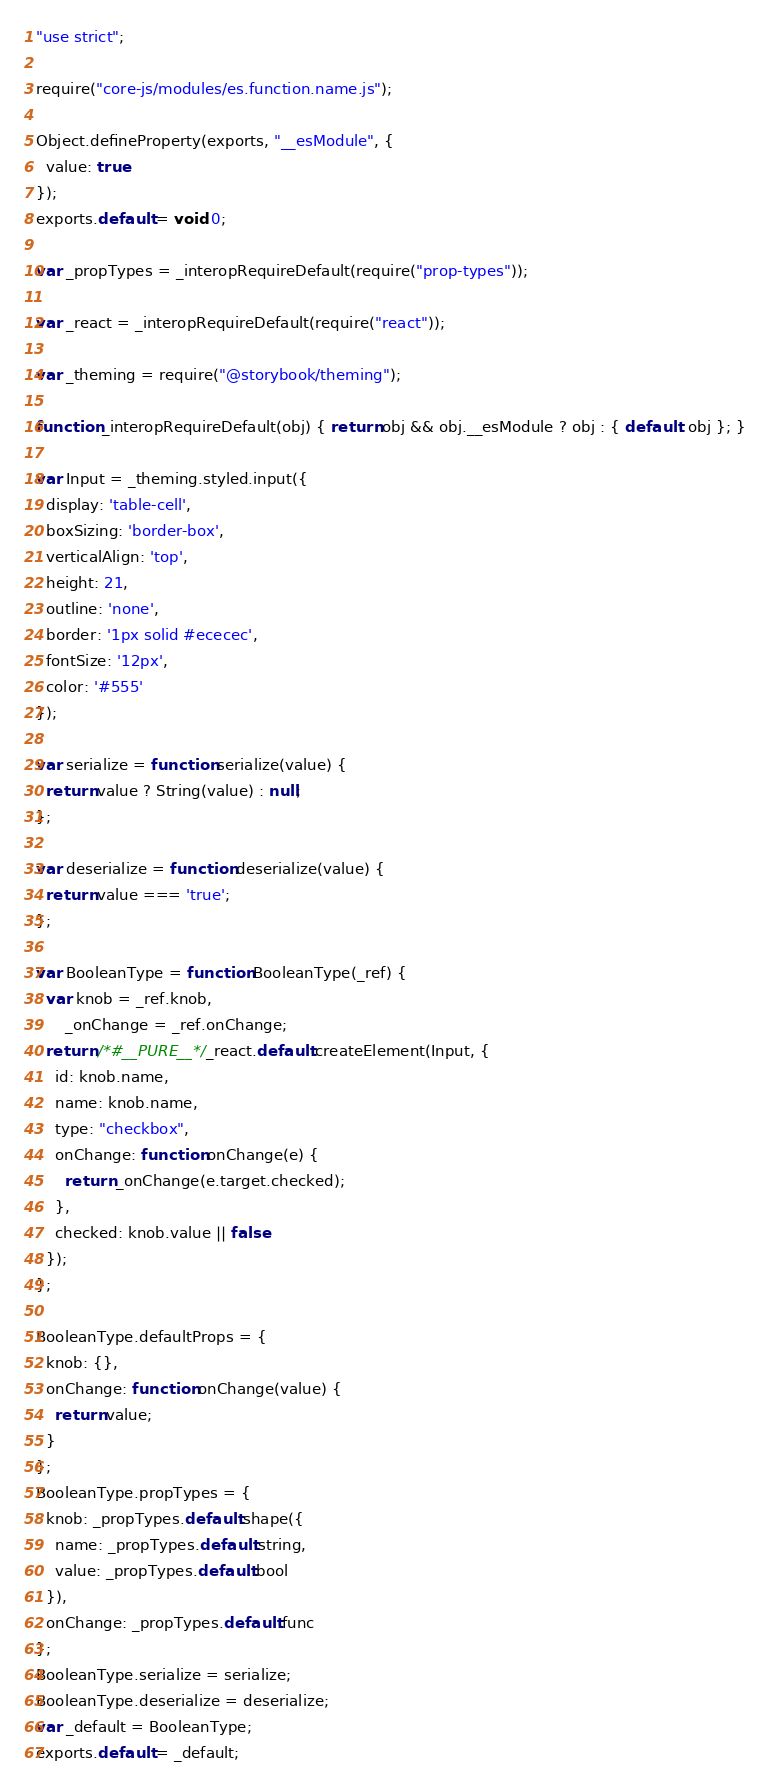Convert code to text. <code><loc_0><loc_0><loc_500><loc_500><_JavaScript_>"use strict";

require("core-js/modules/es.function.name.js");

Object.defineProperty(exports, "__esModule", {
  value: true
});
exports.default = void 0;

var _propTypes = _interopRequireDefault(require("prop-types"));

var _react = _interopRequireDefault(require("react"));

var _theming = require("@storybook/theming");

function _interopRequireDefault(obj) { return obj && obj.__esModule ? obj : { default: obj }; }

var Input = _theming.styled.input({
  display: 'table-cell',
  boxSizing: 'border-box',
  verticalAlign: 'top',
  height: 21,
  outline: 'none',
  border: '1px solid #ececec',
  fontSize: '12px',
  color: '#555'
});

var serialize = function serialize(value) {
  return value ? String(value) : null;
};

var deserialize = function deserialize(value) {
  return value === 'true';
};

var BooleanType = function BooleanType(_ref) {
  var knob = _ref.knob,
      _onChange = _ref.onChange;
  return /*#__PURE__*/_react.default.createElement(Input, {
    id: knob.name,
    name: knob.name,
    type: "checkbox",
    onChange: function onChange(e) {
      return _onChange(e.target.checked);
    },
    checked: knob.value || false
  });
};

BooleanType.defaultProps = {
  knob: {},
  onChange: function onChange(value) {
    return value;
  }
};
BooleanType.propTypes = {
  knob: _propTypes.default.shape({
    name: _propTypes.default.string,
    value: _propTypes.default.bool
  }),
  onChange: _propTypes.default.func
};
BooleanType.serialize = serialize;
BooleanType.deserialize = deserialize;
var _default = BooleanType;
exports.default = _default;</code> 